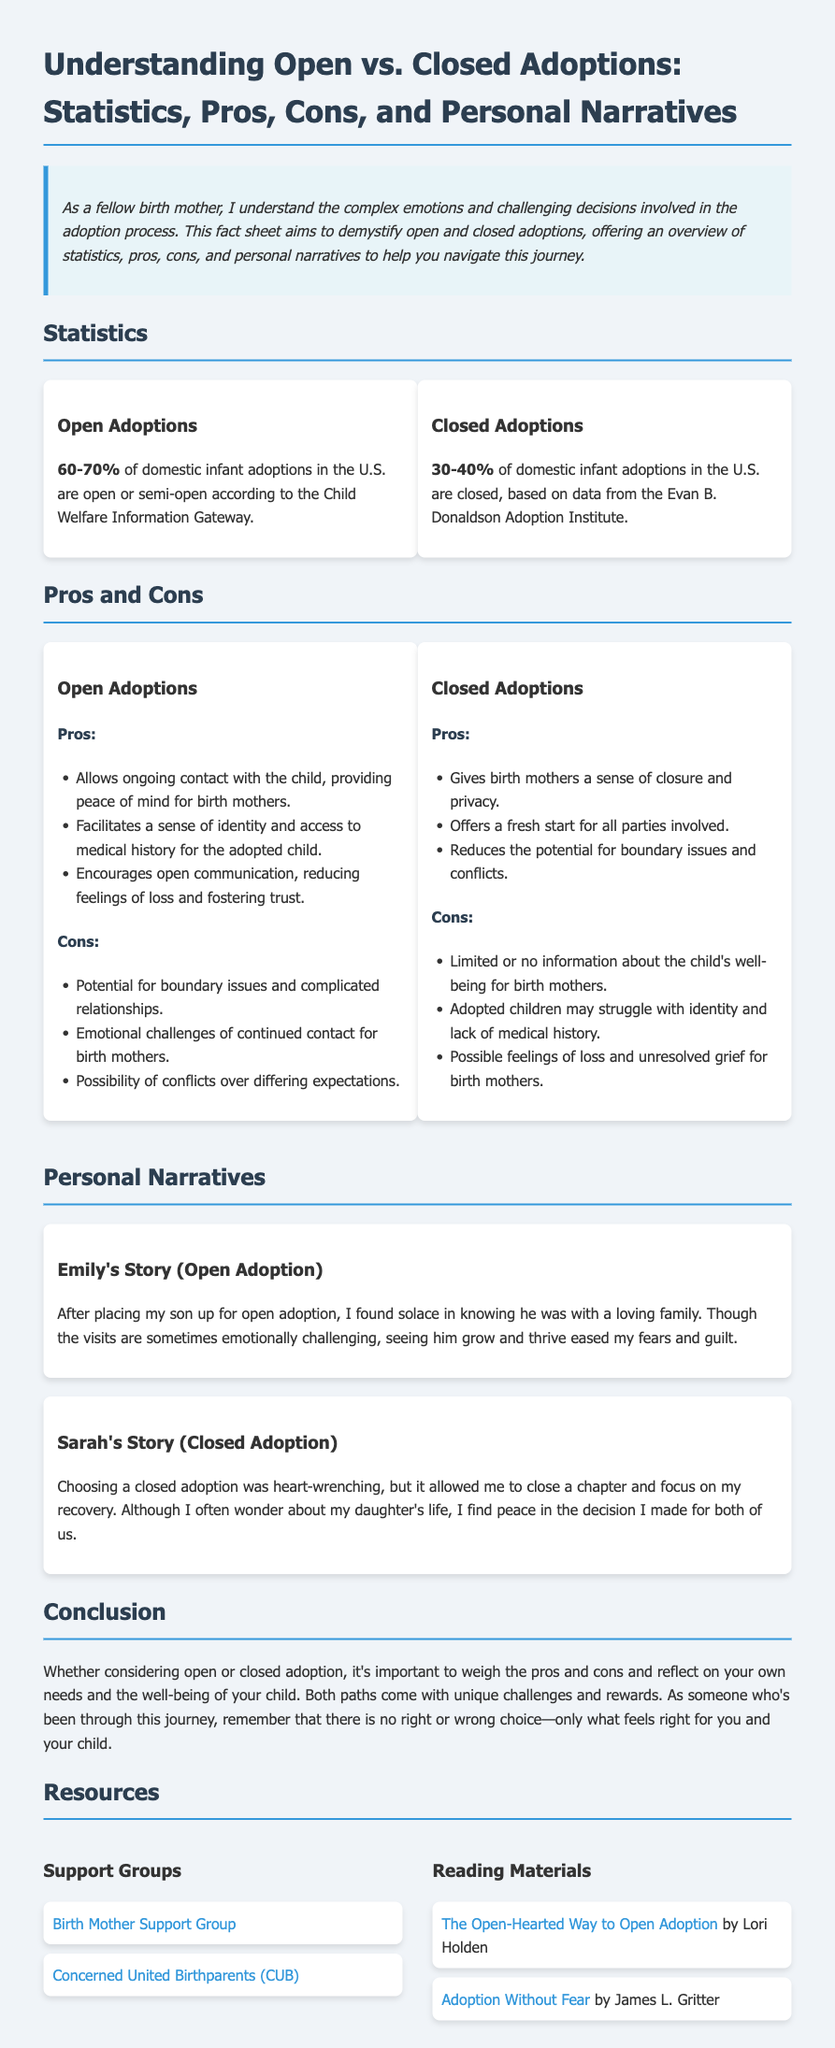What percentage of domestic infant adoptions in the U.S. are open or semi-open? The document states that 60-70% of domestic infant adoptions in the U.S. are open or semi-open according to the Child Welfare Information Gateway.
Answer: 60-70% What are the main emotional challenges of open adoptions for birth mothers? The document outlines that emotional challenges of continued contact could be difficult for birth mothers in open adoptions.
Answer: Continued contact What percentage of domestic infant adoptions in the U.S. are closed? According to the document, 30-40% of domestic infant adoptions in the U.S. are closed, based on data from the Evan B. Donaldson Adoption Institute.
Answer: 30-40% What is a key pro of closed adoptions mentioned in the document? The document lists that a pro of closed adoptions is giving birth mothers a sense of closure and privacy.
Answer: Closure and privacy What narrative is shared for open adoption? Emily's story is shared as a personal narrative for open adoption in the document.
Answer: Emily's Story What is a potential con of closed adoptions? The document specifies that limited or no information about the child's well-being for birth mothers is a potential con of closed adoptions.
Answer: Limited information What is mentioned as a pro of open adoptions? The document indicates that one pro of open adoptions is that it allows ongoing contact with the child, providing peace of mind for birth mothers.
Answer: Ongoing contact What type of resources are provided in the document? The document lists support groups and reading materials as resources for birth mothers.
Answer: Support groups and reading materials 